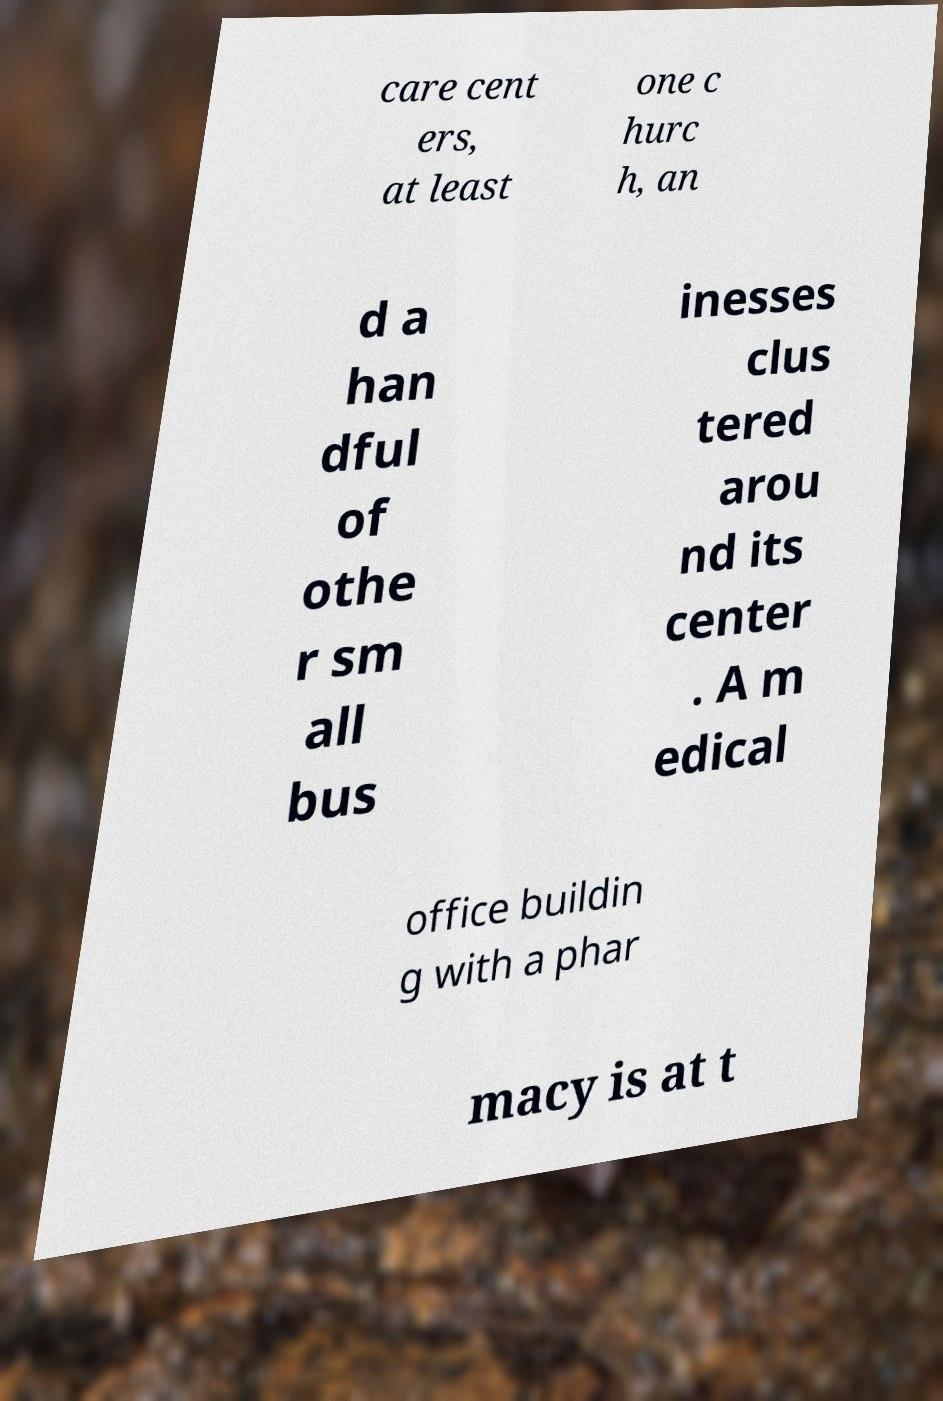Could you assist in decoding the text presented in this image and type it out clearly? care cent ers, at least one c hurc h, an d a han dful of othe r sm all bus inesses clus tered arou nd its center . A m edical office buildin g with a phar macy is at t 